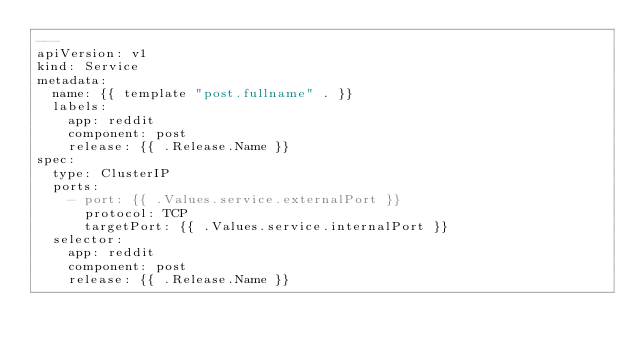Convert code to text. <code><loc_0><loc_0><loc_500><loc_500><_YAML_>---
apiVersion: v1
kind: Service
metadata:
  name: {{ template "post.fullname" . }}
  labels:
    app: reddit
    component: post
    release: {{ .Release.Name }}
spec:
  type: ClusterIP
  ports:
    - port: {{ .Values.service.externalPort }}
      protocol: TCP
      targetPort: {{ .Values.service.internalPort }}
  selector:
    app: reddit
    component: post
    release: {{ .Release.Name }}
</code> 